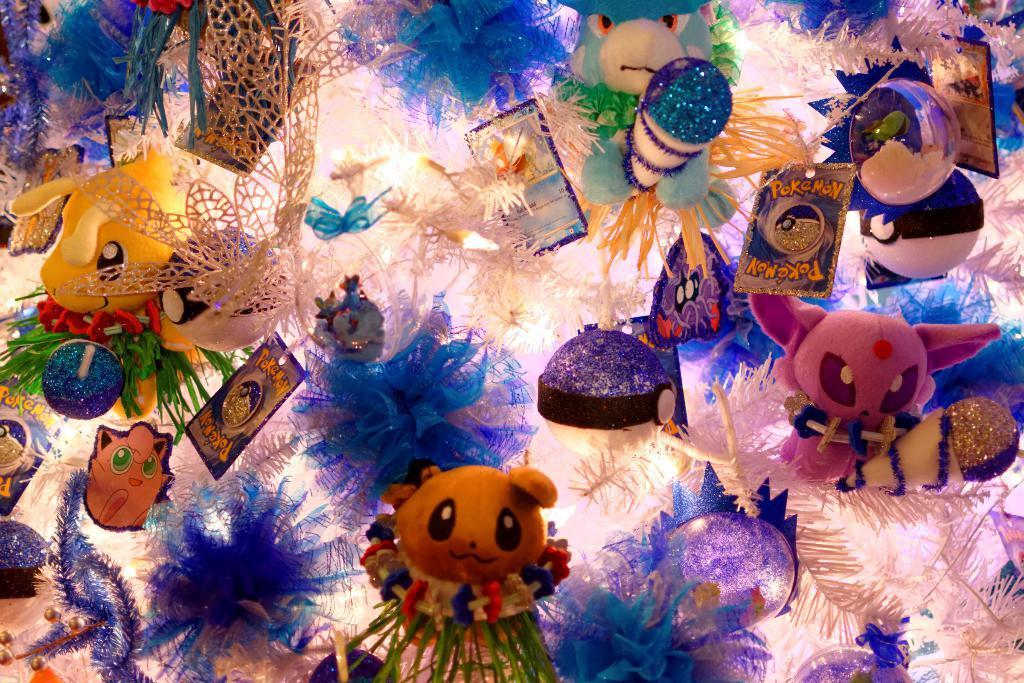Please provide a concise description of this image. There are many toys in this image. 